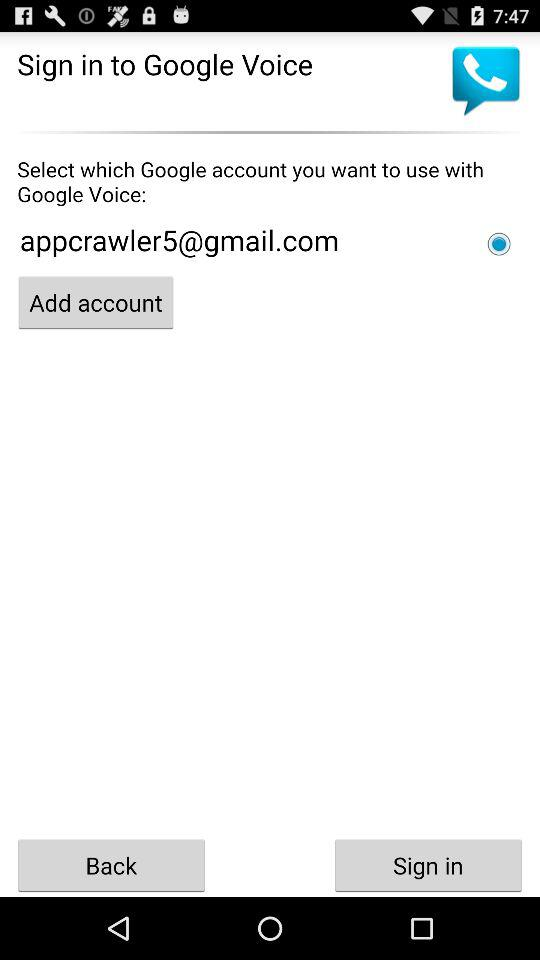What is the name of the application? The name of the application is "Google Voice". 